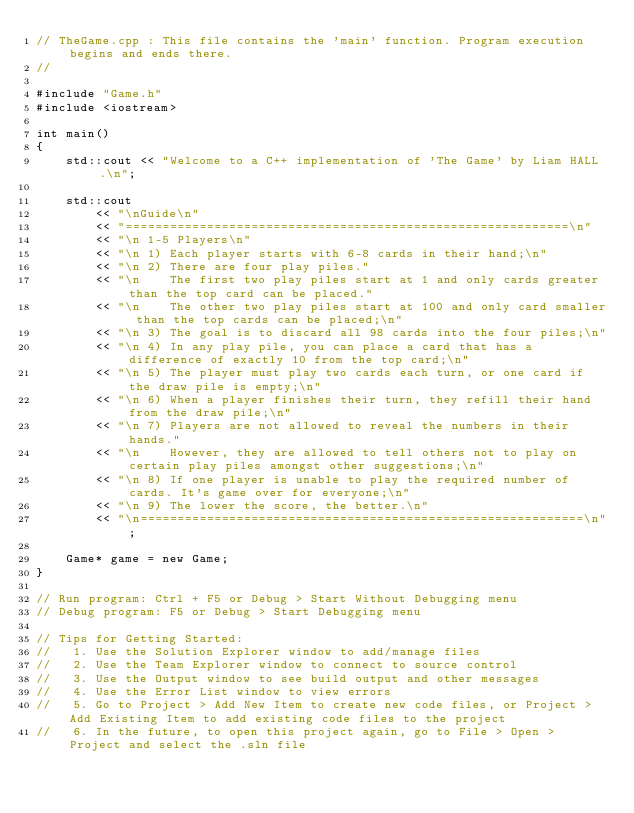Convert code to text. <code><loc_0><loc_0><loc_500><loc_500><_C++_>// TheGame.cpp : This file contains the 'main' function. Program execution begins and ends there.
//

#include "Game.h"
#include <iostream>

int main()
{
    std::cout << "Welcome to a C++ implementation of 'The Game' by Liam HALL.\n";

    std::cout 
        << "\nGuide\n"
        << "============================================================\n"
        << "\n 1-5 Players\n" 
        << "\n 1) Each player starts with 6-8 cards in their hand;\n"
        << "\n 2) There are four play piles."
        << "\n    The first two play piles start at 1 and only cards greater than the top card can be placed."
        << "\n    The other two play piles start at 100 and only card smaller than the top cards can be placed;\n"
        << "\n 3) The goal is to discard all 98 cards into the four piles;\n"
        << "\n 4) In any play pile, you can place a card that has a difference of exactly 10 from the top card;\n"
        << "\n 5) The player must play two cards each turn, or one card if the draw pile is empty;\n"
        << "\n 6) When a player finishes their turn, they refill their hand from the draw pile;\n"
        << "\n 7) Players are not allowed to reveal the numbers in their hands."
        << "\n    However, they are allowed to tell others not to play on certain play piles amongst other suggestions;\n"
        << "\n 8) If one player is unable to play the required number of cards. It's game over for everyone;\n"
        << "\n 9) The lower the score, the better.\n"
        << "\n============================================================\n";

    Game* game = new Game;
}

// Run program: Ctrl + F5 or Debug > Start Without Debugging menu
// Debug program: F5 or Debug > Start Debugging menu

// Tips for Getting Started: 
//   1. Use the Solution Explorer window to add/manage files
//   2. Use the Team Explorer window to connect to source control
//   3. Use the Output window to see build output and other messages
//   4. Use the Error List window to view errors
//   5. Go to Project > Add New Item to create new code files, or Project > Add Existing Item to add existing code files to the project
//   6. In the future, to open this project again, go to File > Open > Project and select the .sln file
</code> 